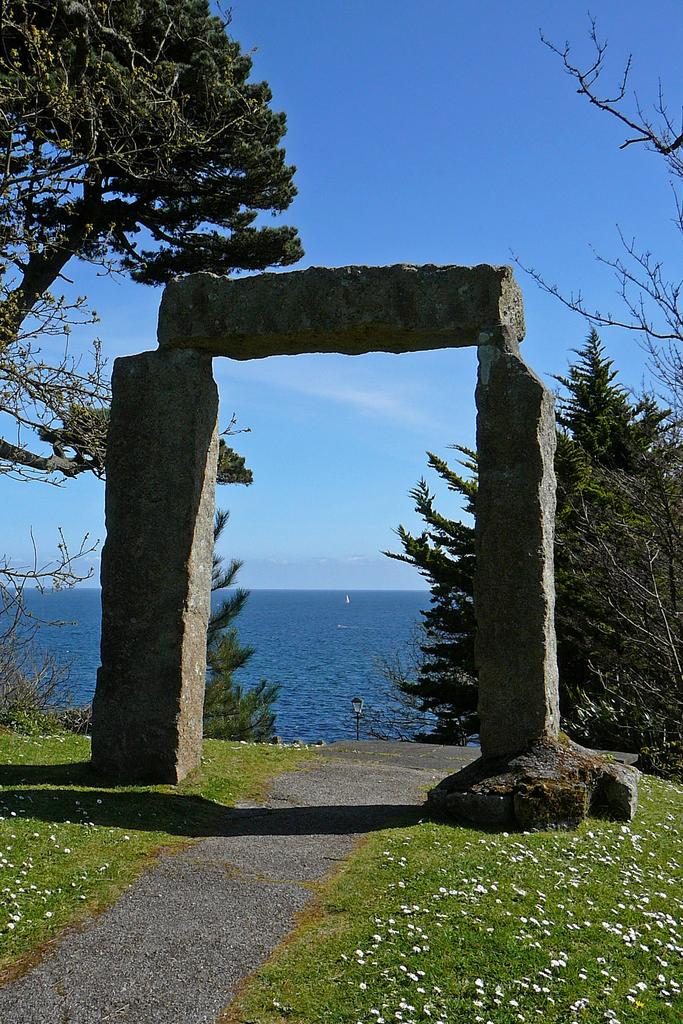What type of structure is present in the image? There is an arch made up of stone in the image. What can be seen on both sides of the arch? There are trees on both sides of the arch. What type of terrain is visible in the image? There is grassland in the image. What is visible in the background of the image? There is a water body in the background of the image. How is the sky depicted in the image? The sky is clear in the image. How many pets are visible in the image? There are no pets present in the image. What type of feather can be seen on the bedroom wall in the image? There is no bedroom or feather present in the image. 